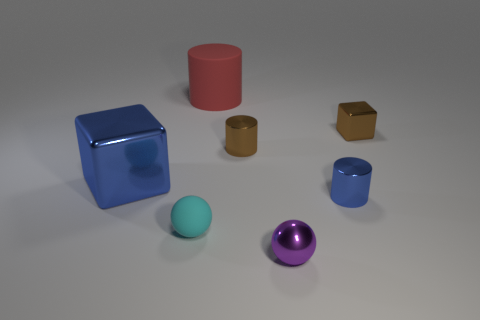There is a small object that is the same color as the large metallic object; what is its material?
Provide a short and direct response. Metal. Are there any other things that are the same size as the blue block?
Offer a very short reply. Yes. How many other objects are the same material as the small purple sphere?
Offer a terse response. 4. What number of things are either brown metallic objects right of the purple sphere or blue shiny objects?
Offer a terse response. 3. What shape is the large thing that is in front of the big thing that is behind the large blue shiny block?
Provide a succinct answer. Cube. Do the shiny object that is on the left side of the big red object and the large red rubber object have the same shape?
Offer a terse response. No. There is a metal cube in front of the brown metal block; what is its color?
Provide a succinct answer. Blue. What number of spheres are tiny brown things or small purple metal things?
Give a very brief answer. 1. How big is the cube that is in front of the small brown object to the left of the tiny brown cube?
Give a very brief answer. Large. There is a tiny rubber thing; is it the same color as the tiny cylinder to the left of the purple thing?
Your answer should be very brief. No. 